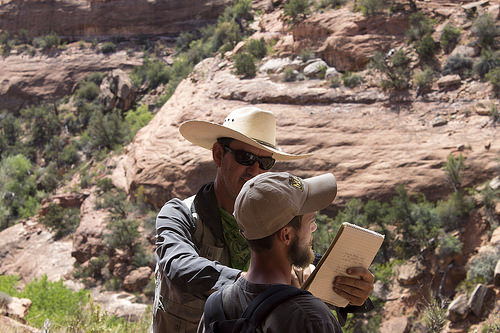<image>
Is there a man in front of the book? Yes. The man is positioned in front of the book, appearing closer to the camera viewpoint. 